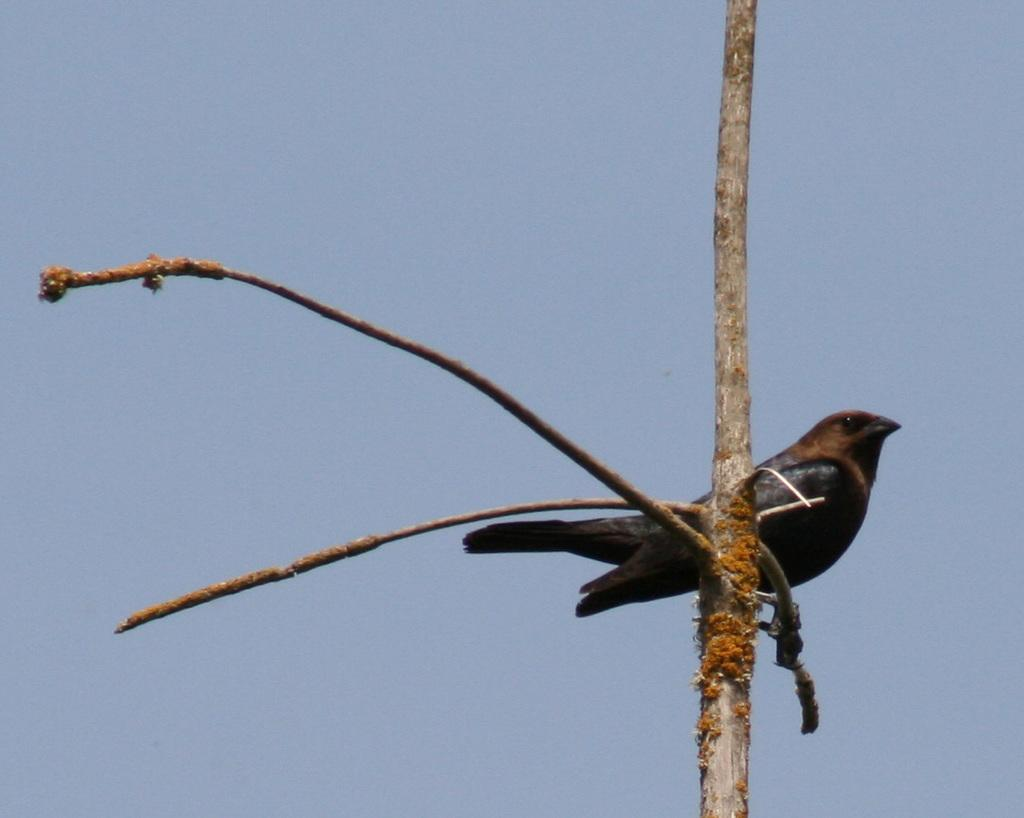Where was the image taken? The image was taken outdoors. What can be seen in the image besides the outdoor setting? There is a tree with stems and a bird on the stem of a tree in the image. What is visible in the background of the image? The sky is visible in the background of the image. What type of list can be seen on the bird's back in the image? There is no list present on the bird's back in the image. What type of cushion is the bird sitting on in the image? There is no cushion present in the image; the bird is sitting on the stem of a tree. 